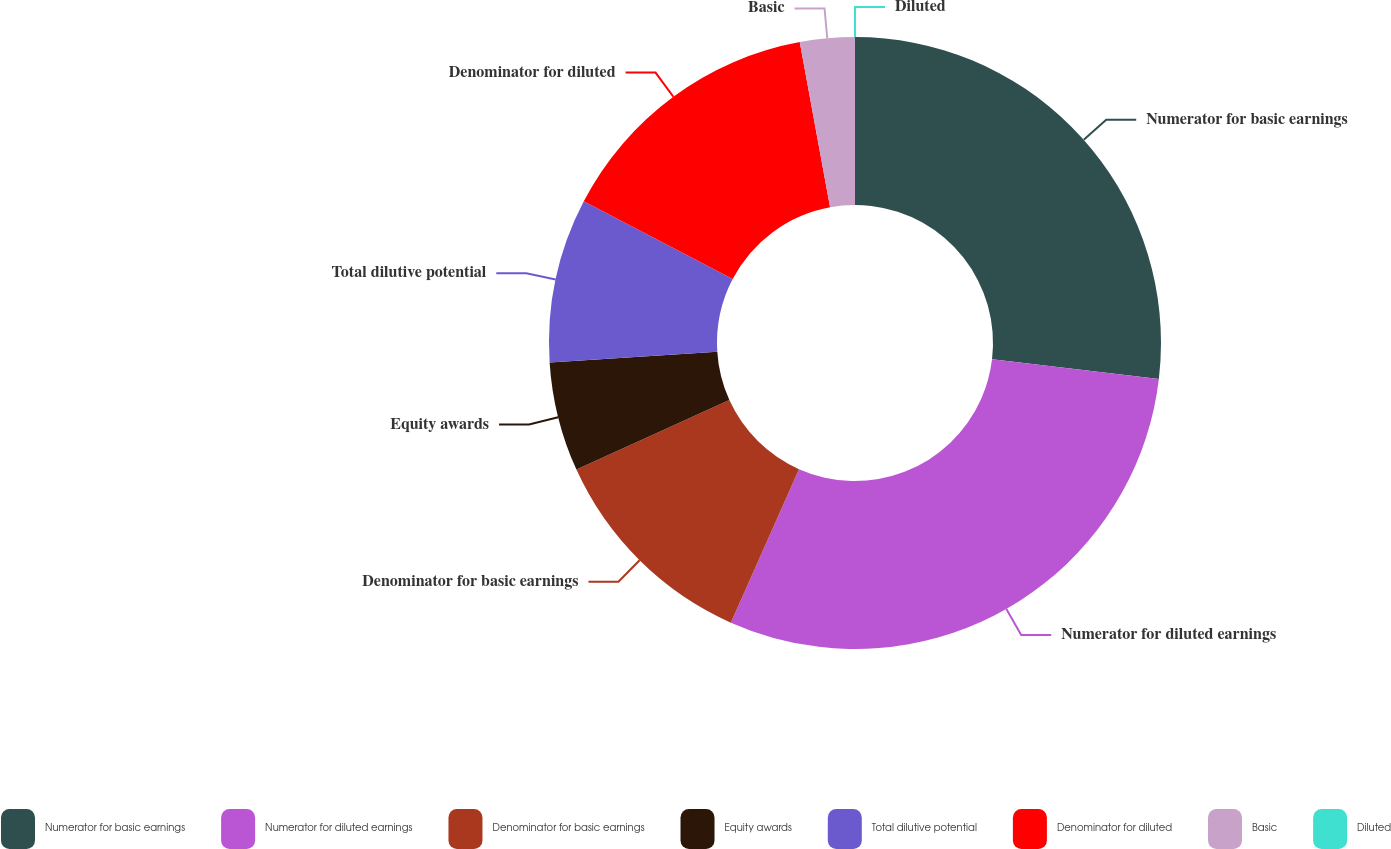<chart> <loc_0><loc_0><loc_500><loc_500><pie_chart><fcel>Numerator for basic earnings<fcel>Numerator for diluted earnings<fcel>Denominator for basic earnings<fcel>Equity awards<fcel>Total dilutive potential<fcel>Denominator for diluted<fcel>Basic<fcel>Diluted<nl><fcel>26.88%<fcel>29.77%<fcel>11.56%<fcel>5.78%<fcel>8.67%<fcel>14.45%<fcel>2.89%<fcel>0.0%<nl></chart> 